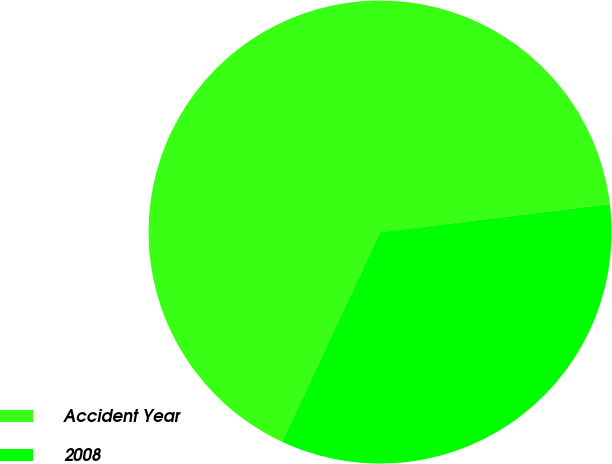Convert chart. <chart><loc_0><loc_0><loc_500><loc_500><pie_chart><fcel>Accident Year<fcel>2008<nl><fcel>66.1%<fcel>33.9%<nl></chart> 